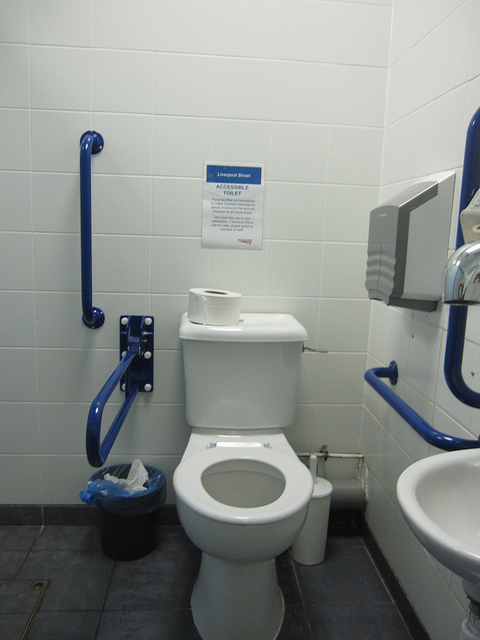Please identify all text content in this image. ACCESSABLE TOILET 